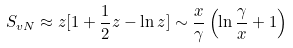Convert formula to latex. <formula><loc_0><loc_0><loc_500><loc_500>S _ { v N } \approx z [ 1 + { \frac { 1 } { 2 } } z - \ln { z } ] \sim { \frac { x } { \gamma } } \left ( \ln { \frac { \gamma } { x } } + 1 \right )</formula> 